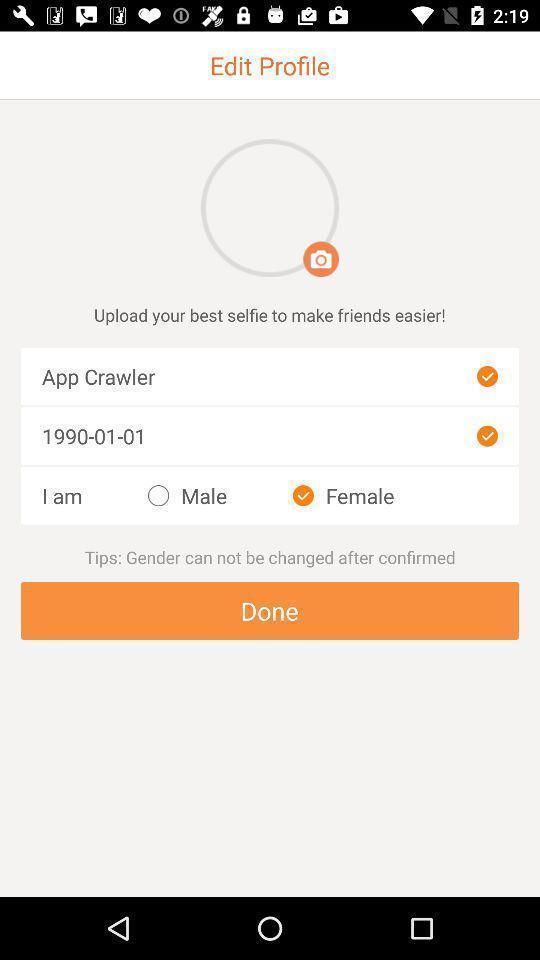Explain the elements present in this screenshot. Screen displaying the edit profile page of a chatting app. 